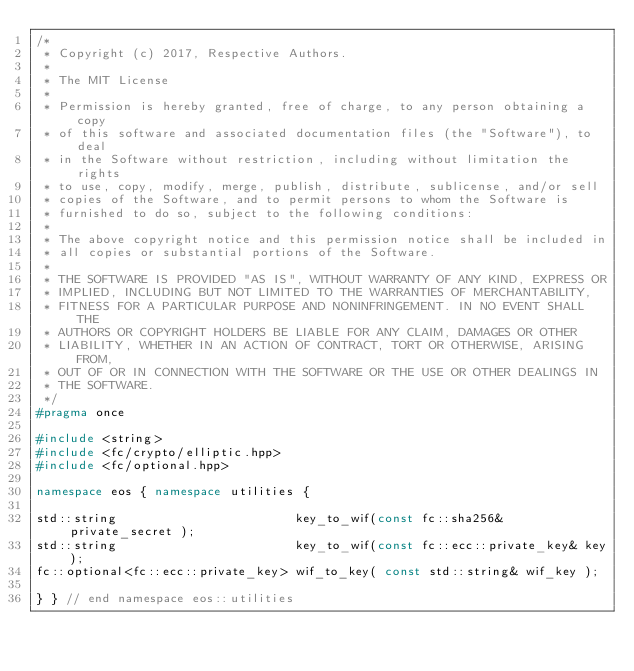Convert code to text. <code><loc_0><loc_0><loc_500><loc_500><_C++_>/*
 * Copyright (c) 2017, Respective Authors.
 *
 * The MIT License
 *
 * Permission is hereby granted, free of charge, to any person obtaining a copy
 * of this software and associated documentation files (the "Software"), to deal
 * in the Software without restriction, including without limitation the rights
 * to use, copy, modify, merge, publish, distribute, sublicense, and/or sell
 * copies of the Software, and to permit persons to whom the Software is
 * furnished to do so, subject to the following conditions:
 *
 * The above copyright notice and this permission notice shall be included in
 * all copies or substantial portions of the Software.
 *
 * THE SOFTWARE IS PROVIDED "AS IS", WITHOUT WARRANTY OF ANY KIND, EXPRESS OR
 * IMPLIED, INCLUDING BUT NOT LIMITED TO THE WARRANTIES OF MERCHANTABILITY,
 * FITNESS FOR A PARTICULAR PURPOSE AND NONINFRINGEMENT. IN NO EVENT SHALL THE
 * AUTHORS OR COPYRIGHT HOLDERS BE LIABLE FOR ANY CLAIM, DAMAGES OR OTHER
 * LIABILITY, WHETHER IN AN ACTION OF CONTRACT, TORT OR OTHERWISE, ARISING FROM,
 * OUT OF OR IN CONNECTION WITH THE SOFTWARE OR THE USE OR OTHER DEALINGS IN
 * THE SOFTWARE.
 */
#pragma once

#include <string>
#include <fc/crypto/elliptic.hpp>
#include <fc/optional.hpp>

namespace eos { namespace utilities {

std::string                        key_to_wif(const fc::sha256& private_secret );
std::string                        key_to_wif(const fc::ecc::private_key& key);
fc::optional<fc::ecc::private_key> wif_to_key( const std::string& wif_key );

} } // end namespace eos::utilities
</code> 